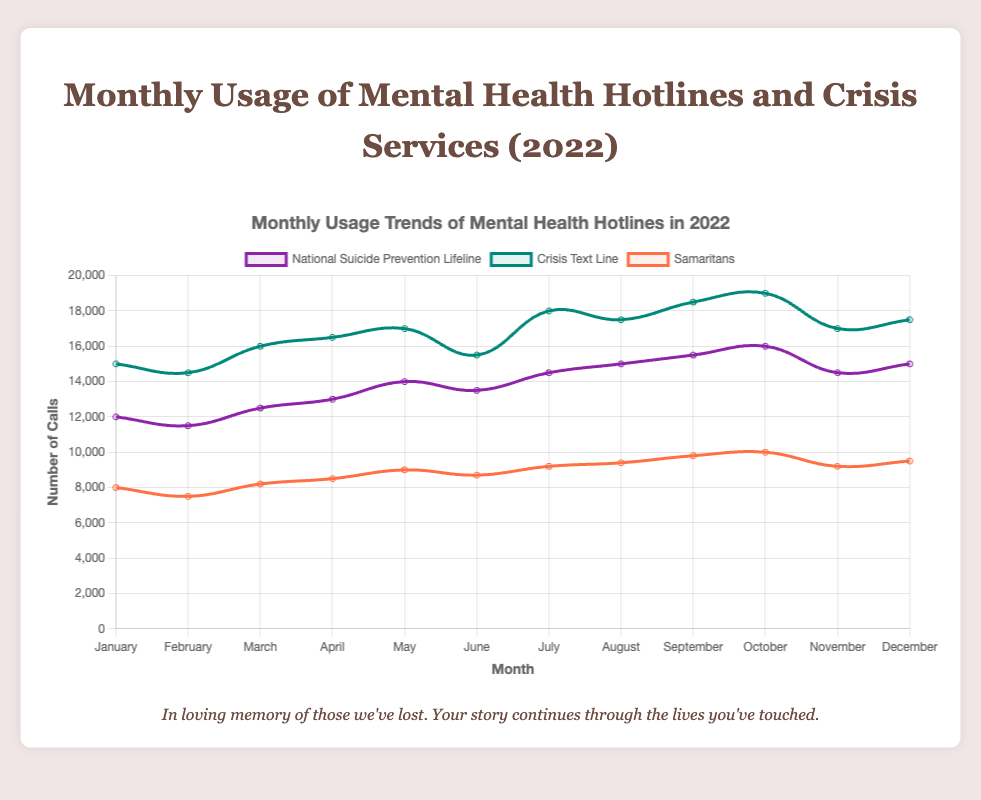Which hotline saw the highest number of calls in December? To find this, we focus on the number of calls for each hotline in December and identify the highest value. According to the data, in December, the National Suicide Prevention Lifeline had 15,000 calls, the Crisis Text Line had 17,500 calls, and the Samaritans had 9,500 calls. The highest number is 17,500 for the Crisis Text Line.
Answer: Crisis Text Line How did the number of calls to the National Suicide Prevention Lifeline change from January to December? We compare the number of calls in January (12,000) with the number of calls in December (15,000). The difference is 15,000 - 12,000 = 3,000, indicating an increase.
Answer: Increased by 3,000 Was there any month where the Crisis Text Line had fewer calls than the National Suicide Prevention Lifeline? To answer this, we compare the monthly counts for both hotlines. In each month, the Crisis Text Line had more calls than the National Suicide Prevention Lifeline, so there were no such months.
Answer: No Which hotline had the most consistent number of calls throughout the year? To determine this, we look at the variability of the number of calls for each hotline. The Crisis Text Line and National Suicide Prevention Lifeline show more fluctuations compared to the Samaritans, which has smaller variations.
Answer: Samaritans Which month saw the highest total calls across all hotlines? We calculate the total for each month by summing the calls for all hotlines. September has the highest total: National Suicide Prevention Lifeline (15,500) + Crisis Text Line (18,500) + Samaritans (9,800) = 43,800.
Answer: September Did the number of calls to the Crisis Text Line ever decrease from one month to the next? If so, when? To determine this, we look for any decreases in the monthly numbers for the Crisis Text Line. Calls decreased from July (18,000) to August (17,500) and from October (19,000) to November (17,000).
Answer: August and November What is the average number of calls per month to the Samaritans in 2022? We sum the monthly values for Samaritans and divide by 12. The total is 8,000 + 7,500 + 8,200 + 8,500 + 9,000 + 8,700 + 9,200 + 9,400 + 9,800 + 10,000 + 9,200 + 9,500 = 107,000. Average is 107,000 / 12 ≈ 8,917.
Answer: 8,917 In which month did the National Suicide Prevention Lifeline receive its peak number of calls? We look for the month with the highest number in the National Suicide Prevention Lifeline series. October has the highest value of 16,000 calls.
Answer: October 